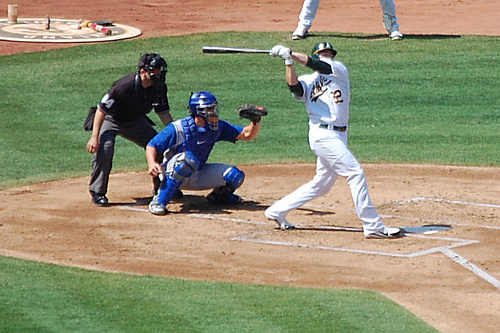Extract all visible text content from this image. 32 